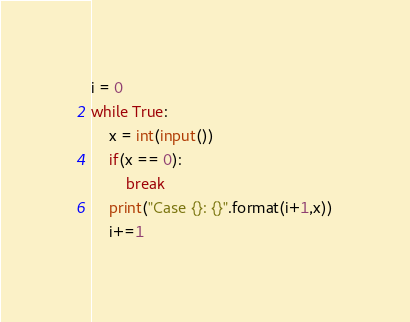Convert code to text. <code><loc_0><loc_0><loc_500><loc_500><_Python_>i = 0
while True:
    x = int(input())
    if(x == 0):
        break
    print("Case {}: {}".format(i+1,x))
    i+=1</code> 